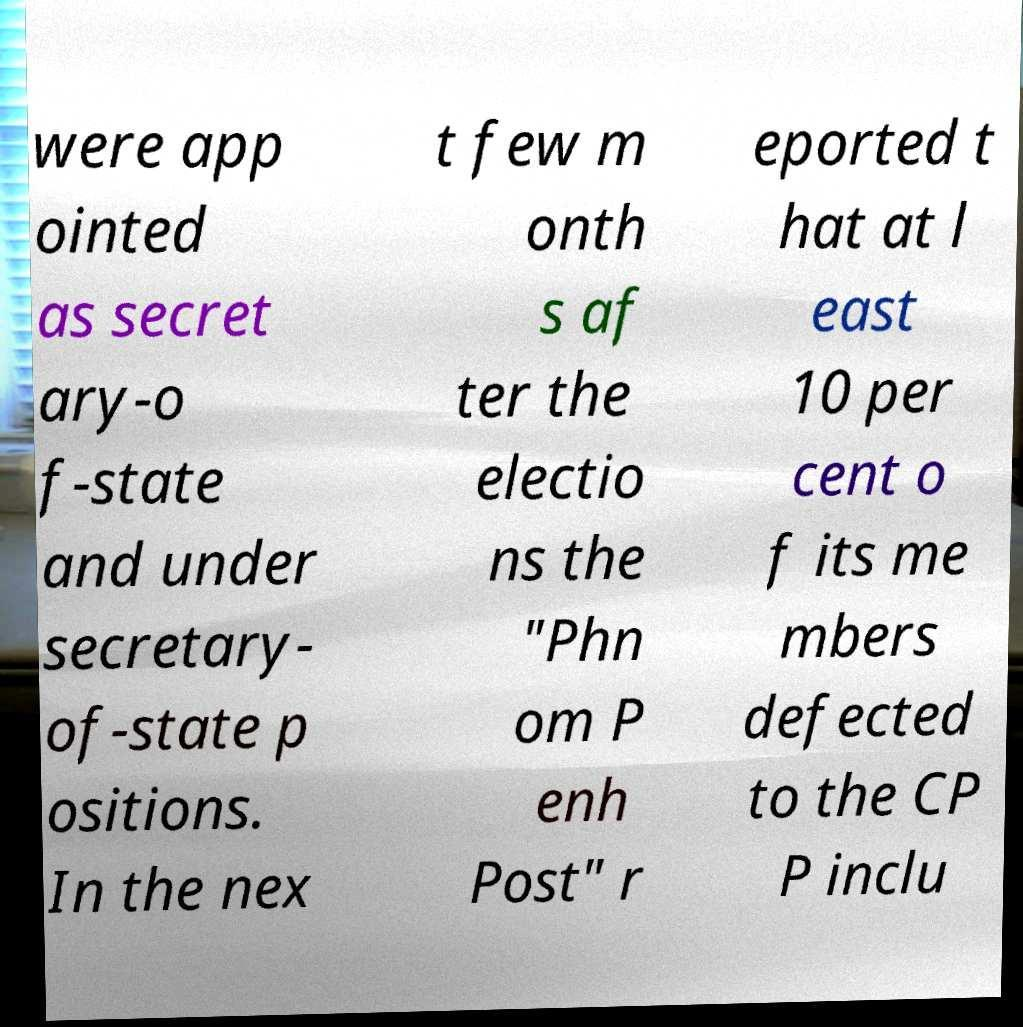Can you accurately transcribe the text from the provided image for me? were app ointed as secret ary-o f-state and under secretary- of-state p ositions. In the nex t few m onth s af ter the electio ns the "Phn om P enh Post" r eported t hat at l east 10 per cent o f its me mbers defected to the CP P inclu 